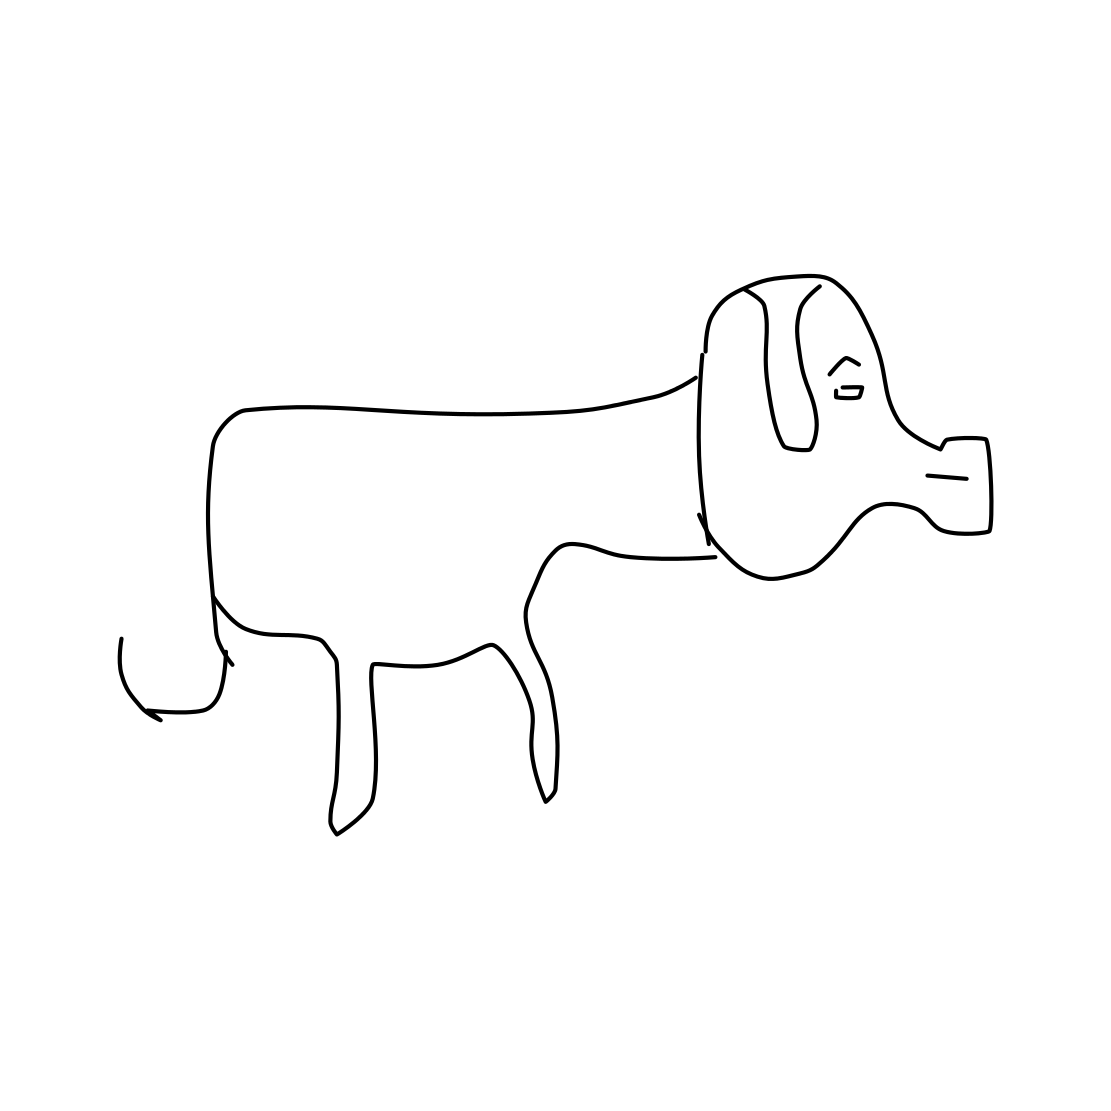What do you imagine the artist's intent was in creating this picture? Given its simplicity, the artist may have aimed for a minimalist effect, focusing on essential details to evoke the image of a dog. It could serve an educational purpose, illustrate a concept with simplicity, or reflect a personal style. 